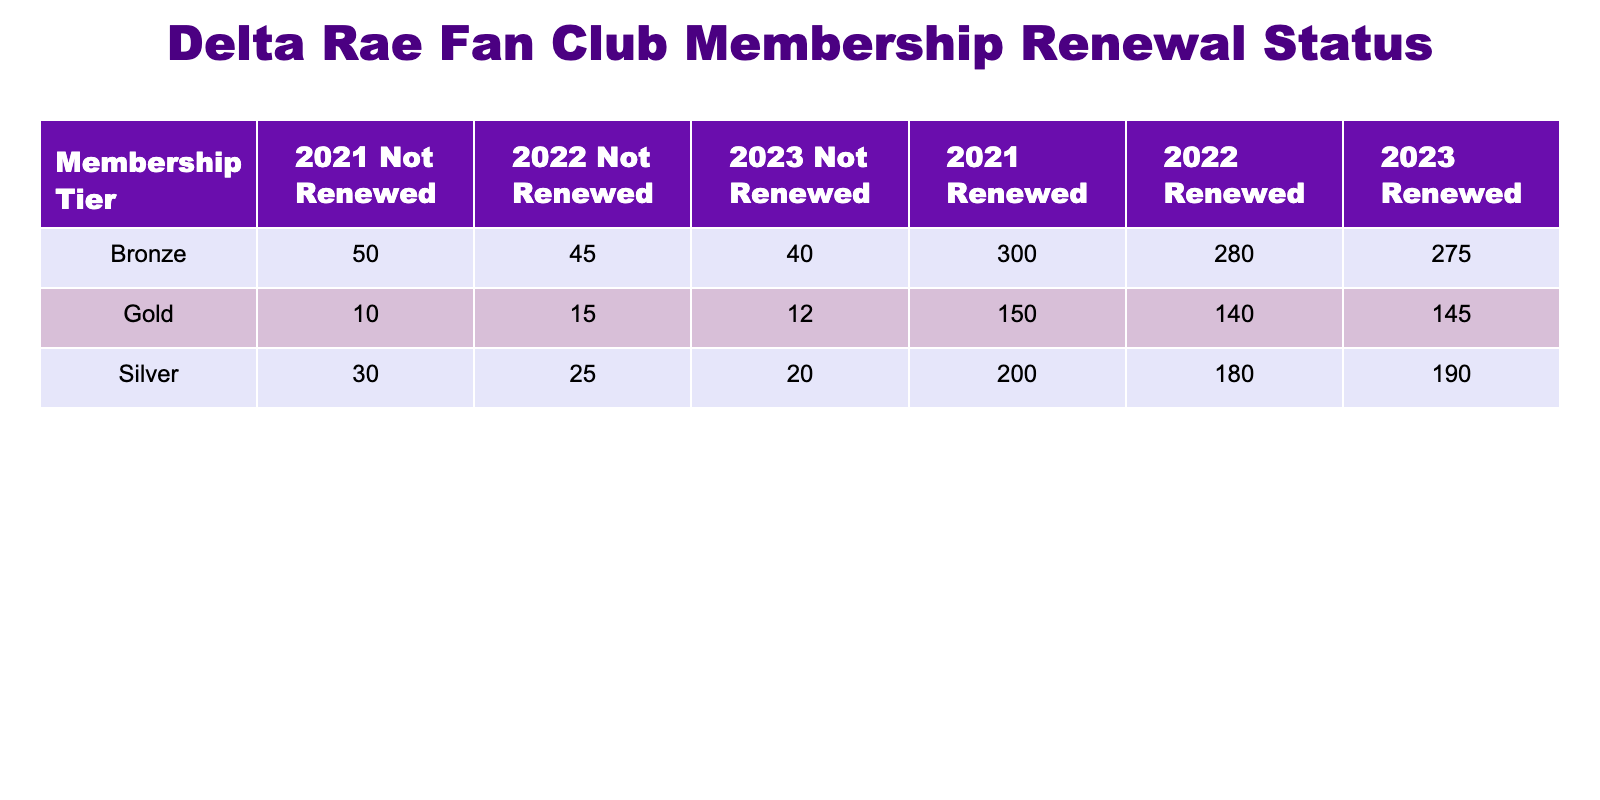What was the total number of Gold memberships that renewed in 2022? In the table, the number of Gold memberships that renewed in 2022 is specifically listed under the column for Gold, Year 2022, Renewed, which is 140.
Answer: 140 How many total Silver memberships were not renewed across all years? To find the total not renewed for Silver memberships, we need to sum the values in the Not Renewed column for Silver across each year: 30 (2021) + 25 (2022) + 20 (2023) = 75.
Answer: 75 Did more Bronze memberships renew in 2021 than Gold memberships? For 2021, Bronze memberships renewed are 300, while Gold memberships renewed are 150. Since 300 is greater than 150, the statement is true.
Answer: Yes What is the total number of memberships (Gold, Silver, Bronze) that were renewed in 2023? To find this total, we sum the Renewed values for each tier in the year 2023: 145 (Gold) + 190 (Silver) + 275 (Bronze) = 610.
Answer: 610 Which membership tier had the highest renewal count in 2021? Reviewing the renewal counts for 2021: Gold has 150, Silver has 200, and Bronze has 300. Since 300 is the highest, the Bronze tier had the highest renewal count.
Answer: Bronze How many more Silver memberships renewed in 2023 compared to 2021? For Silver in 2023, there are 190 renewals and for 2021, there are 200 renewals. The difference is calculated by subtracting the two values: 190 - 200 = -10, indicating a decrease.
Answer: 10 What is the average number of renewals for Gold memberships over the three years? To find the average, we will sum the renewals for Gold from 2021 to 2023: 150 (2021) + 140 (2022) + 145 (2023) = 435. Then, divide by the number of years, which is 3: 435 / 3 = 145.
Answer: 145 Was the renewal count for Silver memberships in 2022 lower than in 2021? The renewal for Silver in 2021 is 200, and in 2022 it is 180. Since 180 is less than 200, it confirms that 2022 had a lower renewal count.
Answer: Yes Which year had the least number of not renewed memberships across all tiers? For each year, we add the Not Renewed counts: 2021: 10 (Gold) + 30 (Silver) + 50 (Bronze) = 90, 2022: 15 + 25 + 45 = 85, 2023: 12 + 20 + 40 = 72. The year with the least is 2023 with 72 not renewed memberships.
Answer: 2023 